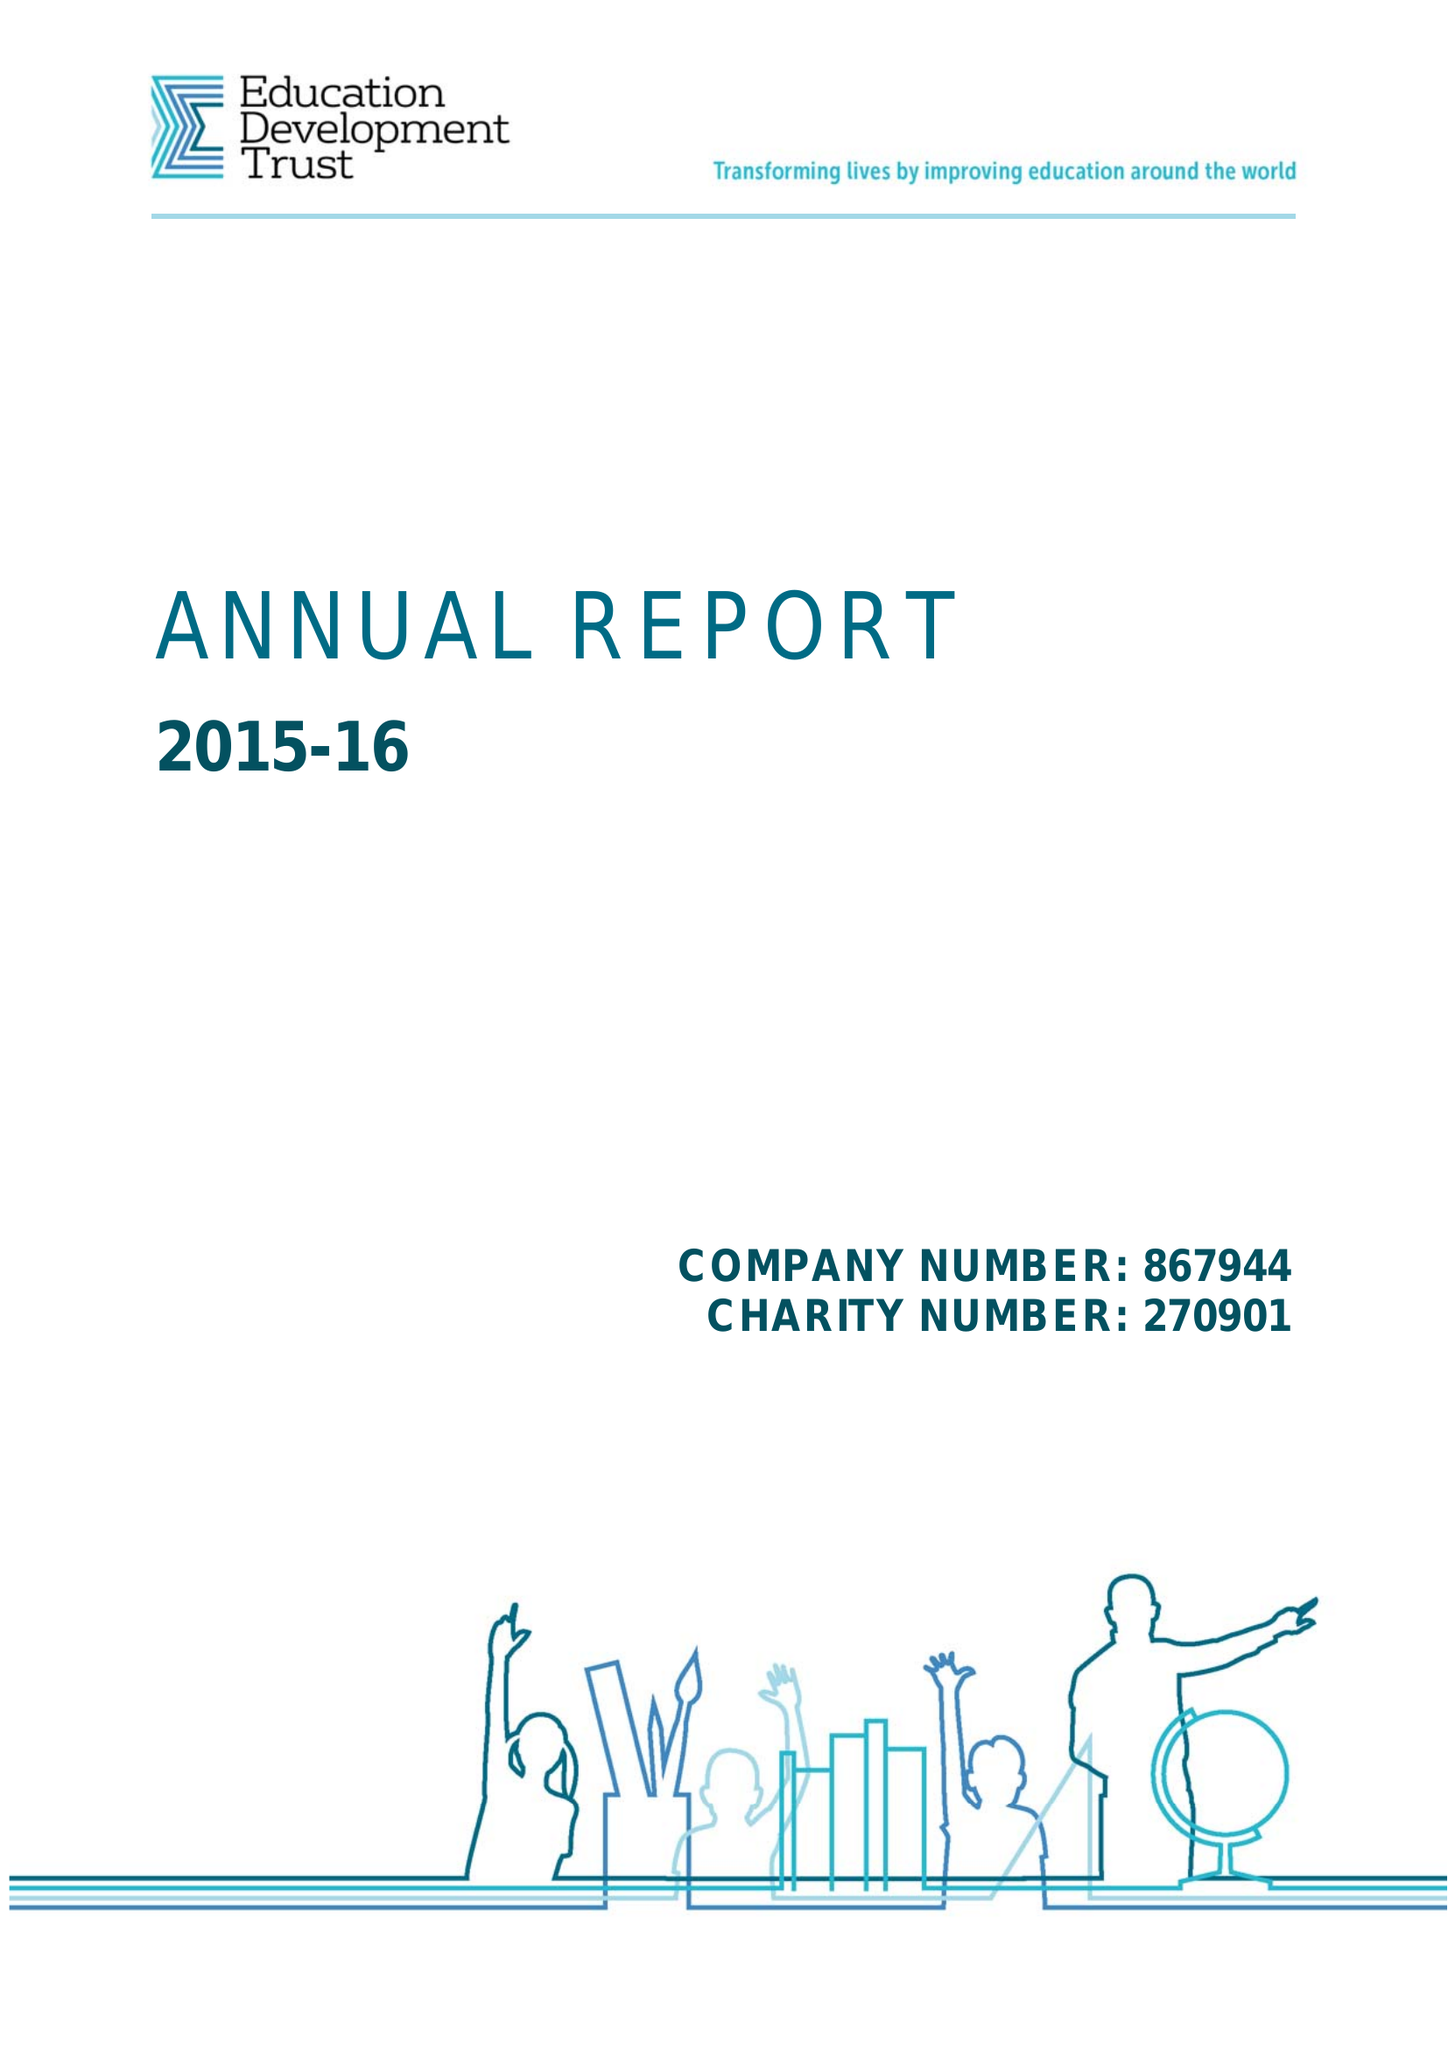What is the value for the address__post_town?
Answer the question using a single word or phrase. READING 